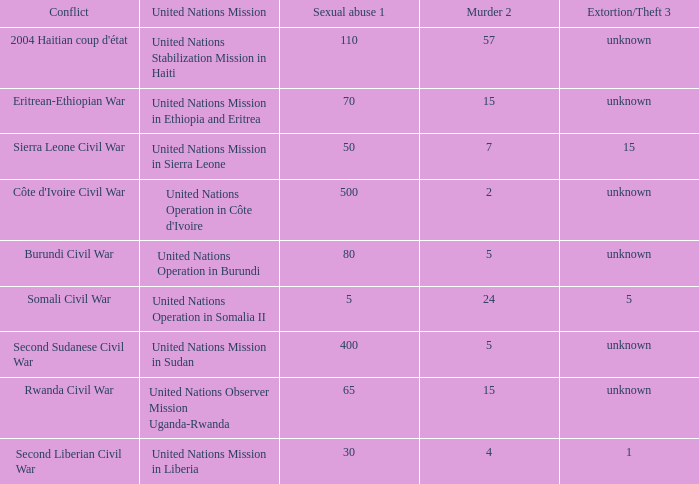What is the sexual abuse rate where the conflict is the Burundi Civil War? 80.0. 